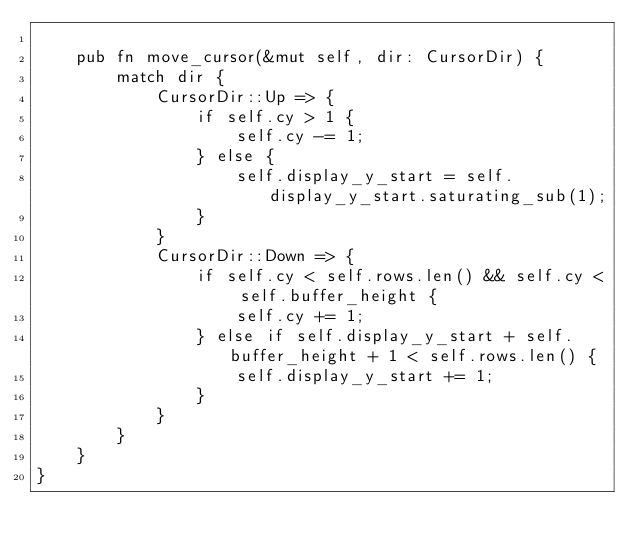Convert code to text. <code><loc_0><loc_0><loc_500><loc_500><_Rust_>
    pub fn move_cursor(&mut self, dir: CursorDir) {
        match dir {
            CursorDir::Up => {
                if self.cy > 1 {
                    self.cy -= 1;
                } else {
                    self.display_y_start = self.display_y_start.saturating_sub(1);
                }
            }
            CursorDir::Down => {
                if self.cy < self.rows.len() && self.cy < self.buffer_height {
                    self.cy += 1;
                } else if self.display_y_start + self.buffer_height + 1 < self.rows.len() {
                    self.display_y_start += 1;
                }
            }
        }
    }
}
</code> 